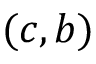<formula> <loc_0><loc_0><loc_500><loc_500>( c , b )</formula> 